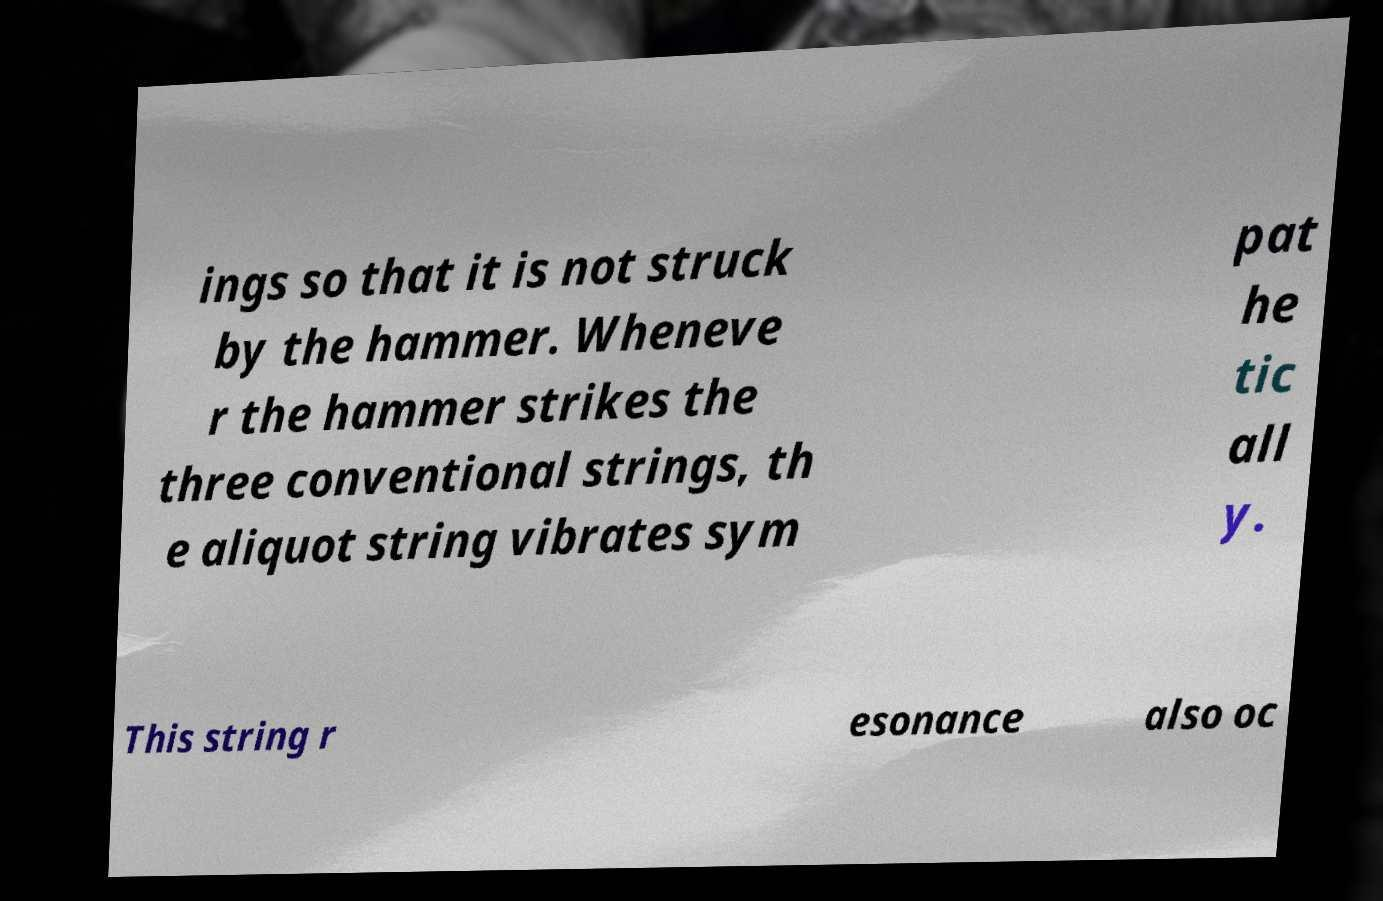Please identify and transcribe the text found in this image. ings so that it is not struck by the hammer. Wheneve r the hammer strikes the three conventional strings, th e aliquot string vibrates sym pat he tic all y. This string r esonance also oc 